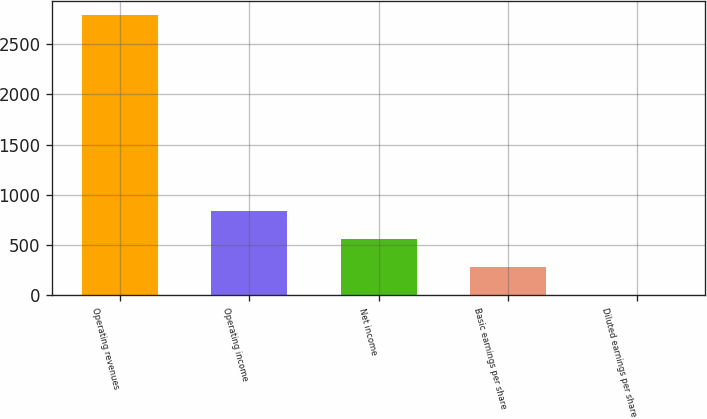<chart> <loc_0><loc_0><loc_500><loc_500><bar_chart><fcel>Operating revenues<fcel>Operating income<fcel>Net income<fcel>Basic earnings per share<fcel>Diluted earnings per share<nl><fcel>2788<fcel>836.93<fcel>558.2<fcel>279.47<fcel>0.74<nl></chart> 